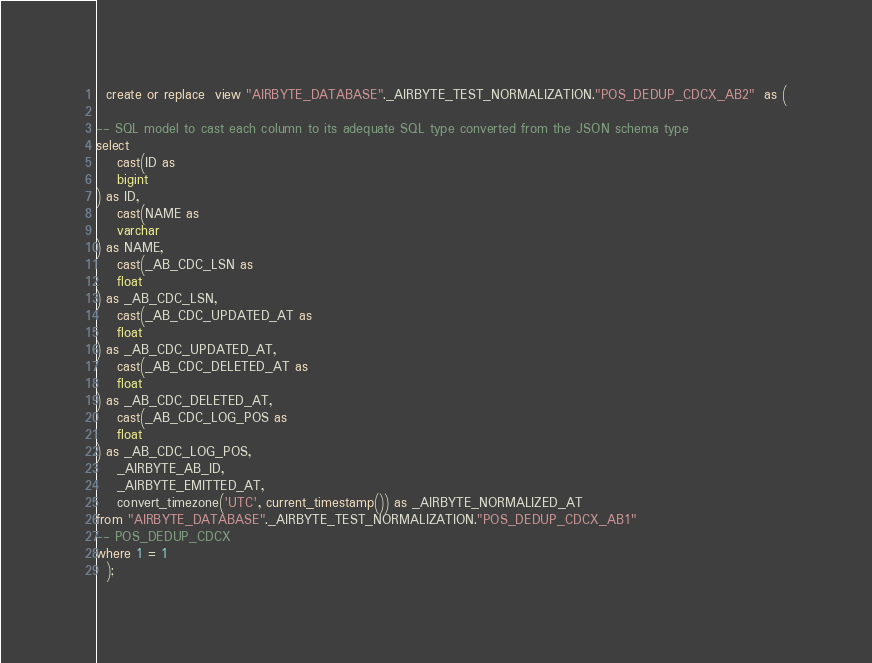Convert code to text. <code><loc_0><loc_0><loc_500><loc_500><_SQL_>
  create or replace  view "AIRBYTE_DATABASE"._AIRBYTE_TEST_NORMALIZATION."POS_DEDUP_CDCX_AB2"  as (
    
-- SQL model to cast each column to its adequate SQL type converted from the JSON schema type
select
    cast(ID as 
    bigint
) as ID,
    cast(NAME as 
    varchar
) as NAME,
    cast(_AB_CDC_LSN as 
    float
) as _AB_CDC_LSN,
    cast(_AB_CDC_UPDATED_AT as 
    float
) as _AB_CDC_UPDATED_AT,
    cast(_AB_CDC_DELETED_AT as 
    float
) as _AB_CDC_DELETED_AT,
    cast(_AB_CDC_LOG_POS as 
    float
) as _AB_CDC_LOG_POS,
    _AIRBYTE_AB_ID,
    _AIRBYTE_EMITTED_AT,
    convert_timezone('UTC', current_timestamp()) as _AIRBYTE_NORMALIZED_AT
from "AIRBYTE_DATABASE"._AIRBYTE_TEST_NORMALIZATION."POS_DEDUP_CDCX_AB1"
-- POS_DEDUP_CDCX
where 1 = 1
  );
</code> 